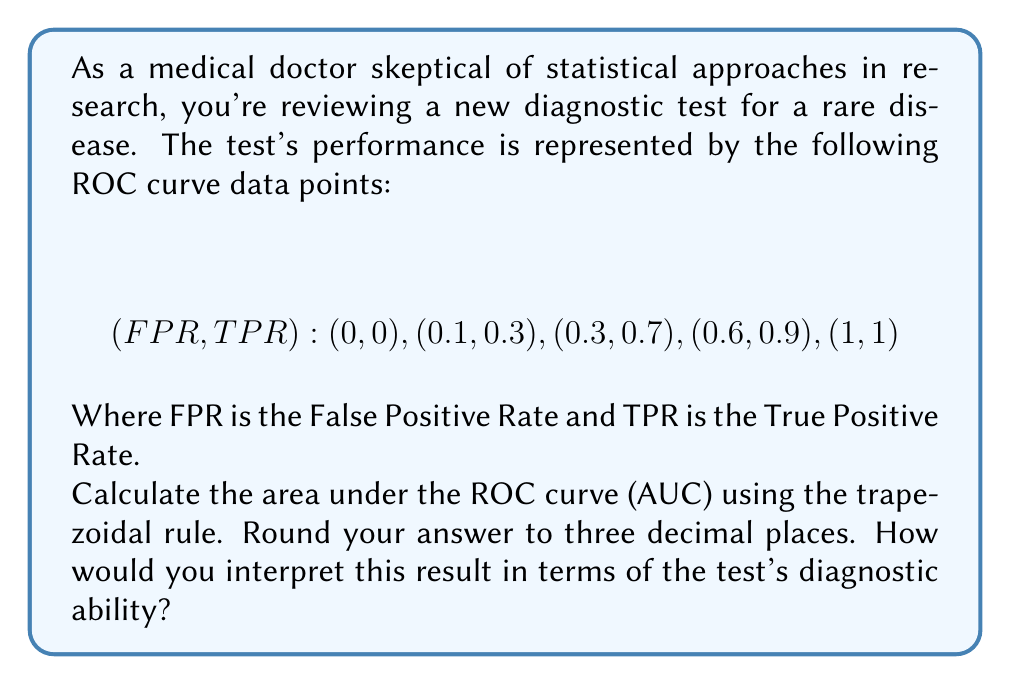Could you help me with this problem? To calculate the area under the ROC curve (AUC) using the trapezoidal rule, we'll follow these steps:

1) The trapezoidal rule approximates the area under a curve by dividing it into trapezoids and summing their areas.

2) For each pair of consecutive points, we calculate the area of the trapezoid formed:

   Area of trapezoid = $\frac{1}{2}(x_2 - x_1)(y_1 + y_2)$

   Where $(x_1, y_1)$ and $(x_2, y_2)$ are consecutive points.

3) Let's calculate each trapezoid area:

   Between (0, 0) and (0.1, 0.3):
   $$\frac{1}{2}(0.1 - 0)(0 + 0.3) = 0.015$$

   Between (0.1, 0.3) and (0.3, 0.7):
   $$\frac{1}{2}(0.3 - 0.1)(0.3 + 0.7) = 0.1$$

   Between (0.3, 0.7) and (0.6, 0.9):
   $$\frac{1}{2}(0.6 - 0.3)(0.7 + 0.9) = 0.24$$

   Between (0.6, 0.9) and (1, 1):
   $$\frac{1}{2}(1 - 0.6)(0.9 + 1) = 0.38$$

4) Sum all trapezoid areas:
   $$0.015 + 0.1 + 0.24 + 0.38 = 0.735$$

5) Rounding to three decimal places: 0.735

Interpretation: The AUC of 0.735 suggests that the diagnostic test has moderate discriminatory power. An AUC of 0.5 represents a test no better than random chance, while 1.0 represents a perfect test. This test performs better than chance but is not highly accurate. As a skeptical medical doctor, you might question whether this level of accuracy is sufficient for clinical use, especially for a rare disease where false positives could lead to unnecessary treatments or anxiety.
Answer: The area under the ROC curve (AUC) is 0.735. 